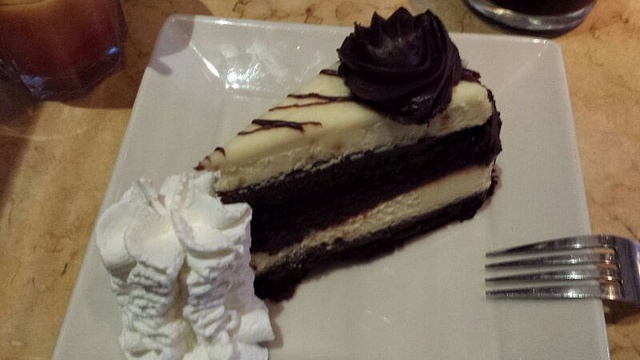Describe the objects in this image and their specific colors. I can see dining table in darkgray, black, gray, and tan tones, cake in maroon, black, darkgray, gray, and tan tones, cup in maroon, black, and purple tones, fork in maroon, gray, black, and darkgray tones, and cup in maroon, black, and gray tones in this image. 